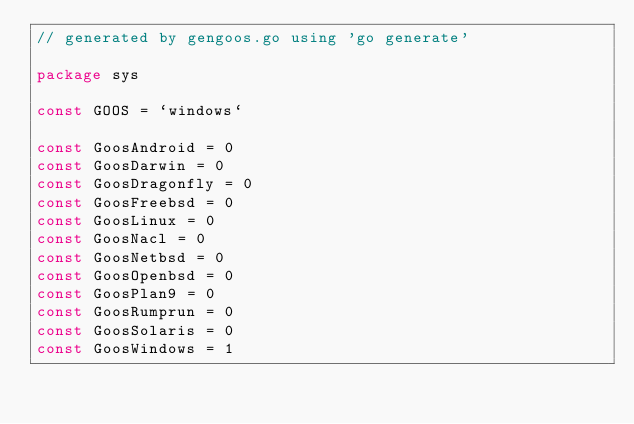<code> <loc_0><loc_0><loc_500><loc_500><_Go_>// generated by gengoos.go using 'go generate'

package sys

const GOOS = `windows`

const GoosAndroid = 0
const GoosDarwin = 0
const GoosDragonfly = 0
const GoosFreebsd = 0
const GoosLinux = 0
const GoosNacl = 0
const GoosNetbsd = 0
const GoosOpenbsd = 0
const GoosPlan9 = 0
const GoosRumprun = 0
const GoosSolaris = 0
const GoosWindows = 1
</code> 